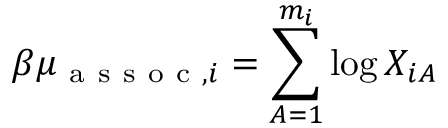Convert formula to latex. <formula><loc_0><loc_0><loc_500><loc_500>{ \beta \mu _ { a s s o c , i } = \sum _ { A = 1 } ^ { m _ { i } } \log X _ { i A } }</formula> 